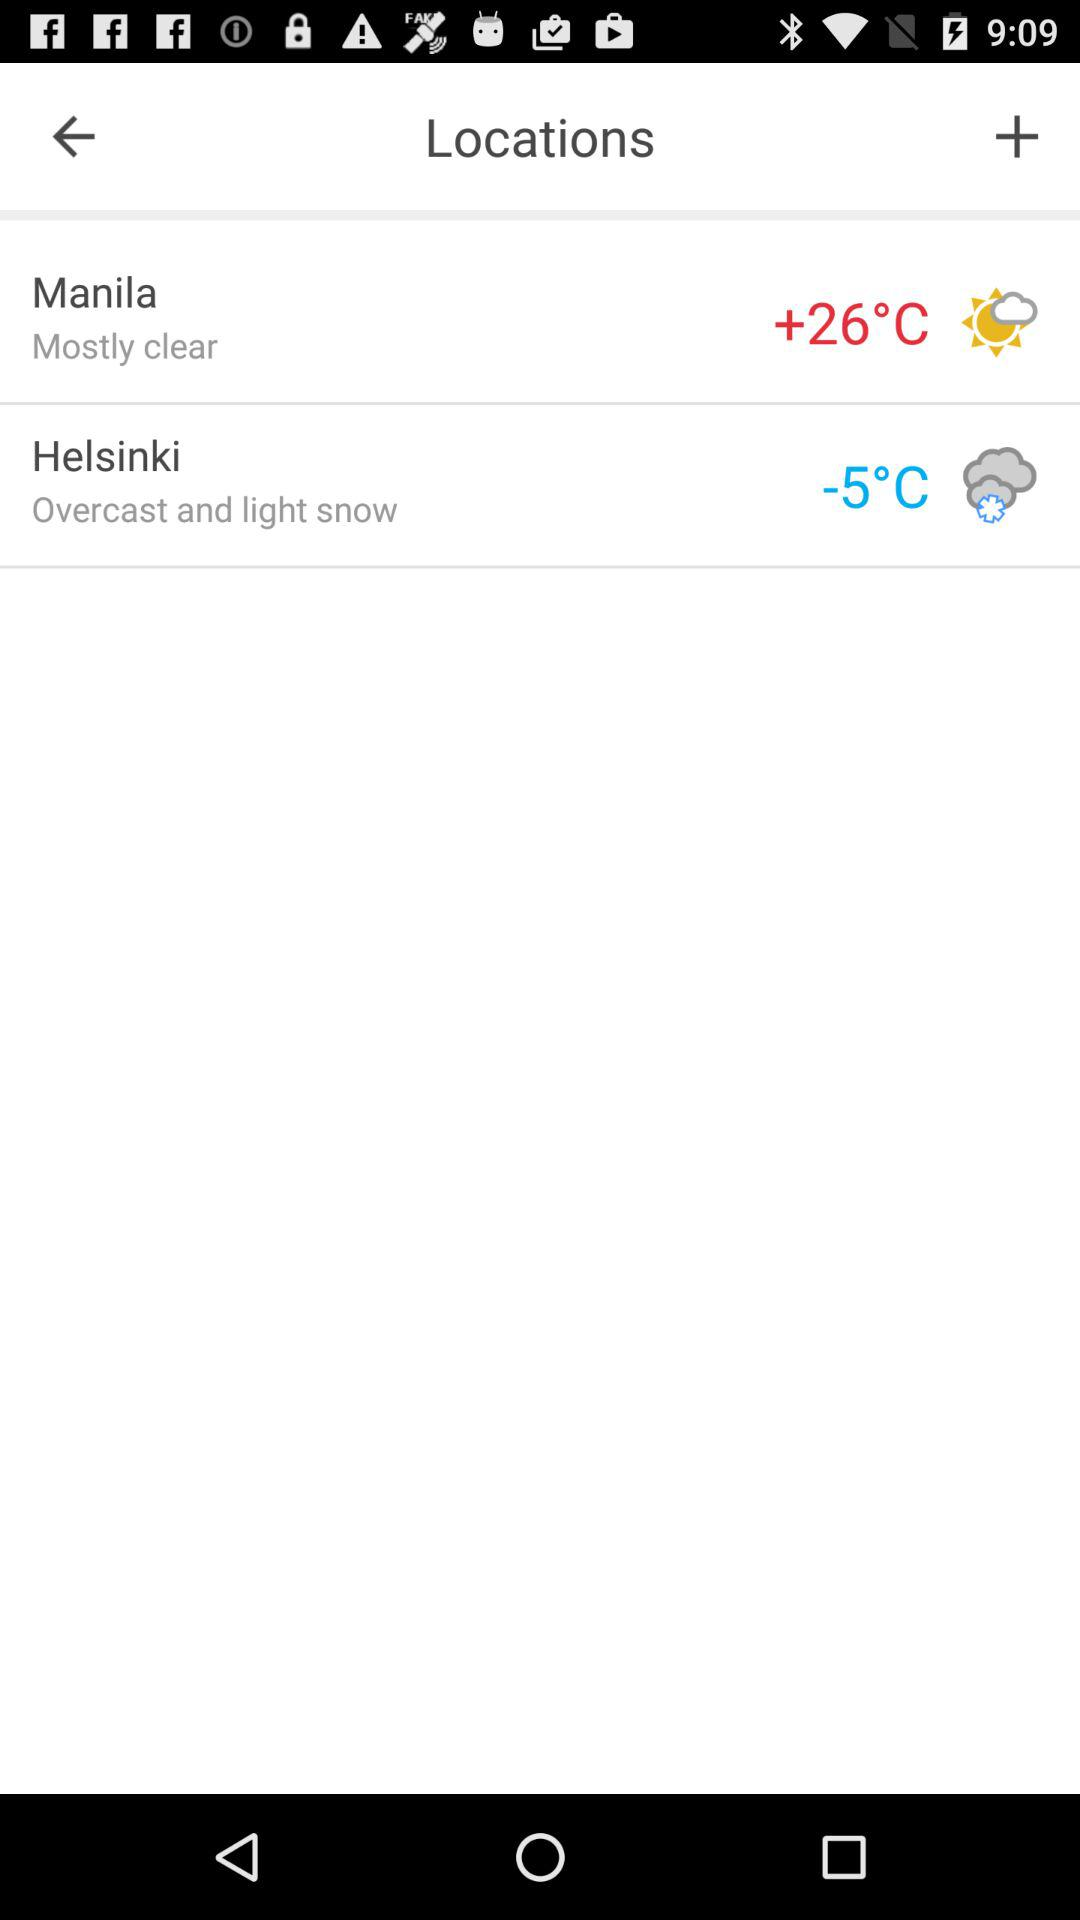Which city is colder, Helsinki or Manila?
Answer the question using a single word or phrase. Helsinki 